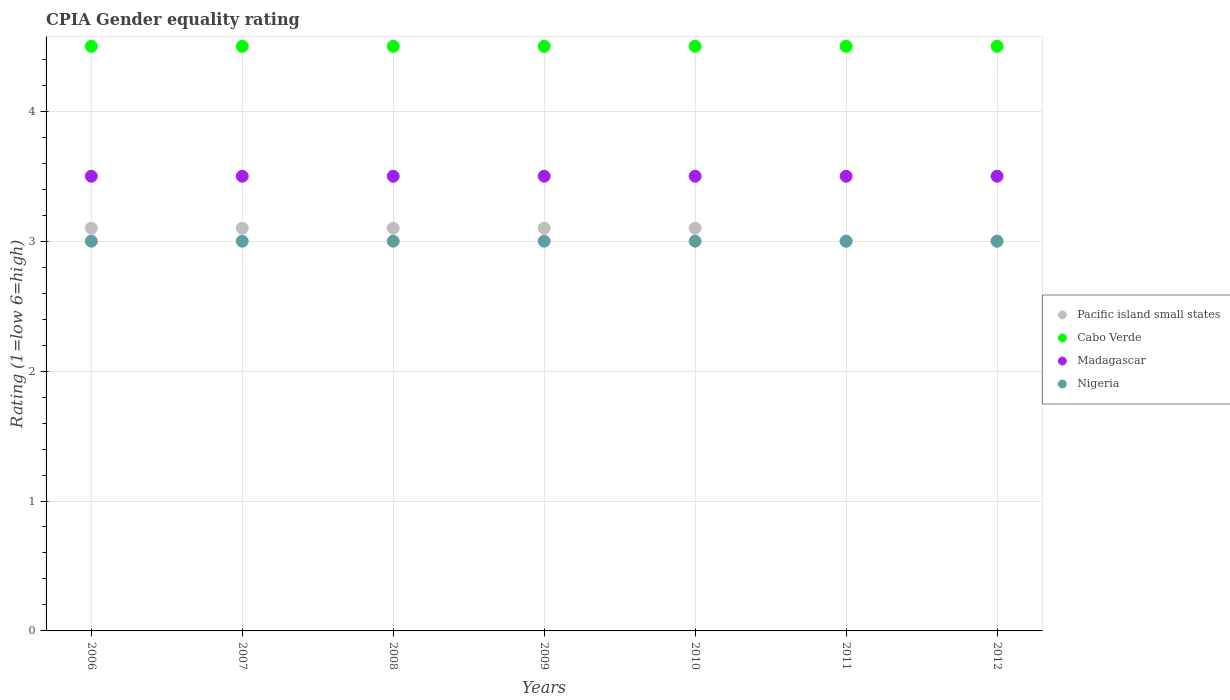Across all years, what is the minimum CPIA rating in Pacific island small states?
Offer a terse response. 3. What is the total CPIA rating in Nigeria in the graph?
Provide a short and direct response. 21. What is the difference between the CPIA rating in Madagascar in 2008 and that in 2012?
Make the answer very short. 0. What is the difference between the CPIA rating in Nigeria in 2007 and the CPIA rating in Cabo Verde in 2010?
Make the answer very short. -1.5. What is the average CPIA rating in Nigeria per year?
Offer a terse response. 3. Is the difference between the CPIA rating in Pacific island small states in 2006 and 2008 greater than the difference between the CPIA rating in Cabo Verde in 2006 and 2008?
Give a very brief answer. No. What is the difference between the highest and the second highest CPIA rating in Cabo Verde?
Provide a short and direct response. 0. In how many years, is the CPIA rating in Nigeria greater than the average CPIA rating in Nigeria taken over all years?
Ensure brevity in your answer.  0. Does the CPIA rating in Nigeria monotonically increase over the years?
Give a very brief answer. No. Is the CPIA rating in Nigeria strictly greater than the CPIA rating in Pacific island small states over the years?
Provide a succinct answer. No. Is the CPIA rating in Pacific island small states strictly less than the CPIA rating in Madagascar over the years?
Provide a succinct answer. Yes. How many dotlines are there?
Make the answer very short. 4. Are the values on the major ticks of Y-axis written in scientific E-notation?
Make the answer very short. No. What is the title of the graph?
Your response must be concise. CPIA Gender equality rating. What is the label or title of the Y-axis?
Offer a terse response. Rating (1=low 6=high). What is the Rating (1=low 6=high) in Cabo Verde in 2006?
Provide a succinct answer. 4.5. What is the Rating (1=low 6=high) in Nigeria in 2006?
Keep it short and to the point. 3. What is the Rating (1=low 6=high) of Pacific island small states in 2008?
Offer a very short reply. 3.1. What is the Rating (1=low 6=high) in Madagascar in 2008?
Provide a succinct answer. 3.5. What is the Rating (1=low 6=high) of Cabo Verde in 2009?
Give a very brief answer. 4.5. What is the Rating (1=low 6=high) of Cabo Verde in 2010?
Ensure brevity in your answer.  4.5. What is the Rating (1=low 6=high) in Madagascar in 2010?
Keep it short and to the point. 3.5. What is the Rating (1=low 6=high) in Pacific island small states in 2011?
Offer a very short reply. 3. What is the Rating (1=low 6=high) of Madagascar in 2011?
Your answer should be very brief. 3.5. What is the Rating (1=low 6=high) of Madagascar in 2012?
Make the answer very short. 3.5. Across all years, what is the minimum Rating (1=low 6=high) of Pacific island small states?
Offer a terse response. 3. What is the total Rating (1=low 6=high) of Cabo Verde in the graph?
Provide a short and direct response. 31.5. What is the difference between the Rating (1=low 6=high) in Pacific island small states in 2006 and that in 2007?
Make the answer very short. 0. What is the difference between the Rating (1=low 6=high) of Cabo Verde in 2006 and that in 2007?
Make the answer very short. 0. What is the difference between the Rating (1=low 6=high) in Madagascar in 2006 and that in 2007?
Your answer should be very brief. 0. What is the difference between the Rating (1=low 6=high) in Pacific island small states in 2006 and that in 2009?
Your response must be concise. 0. What is the difference between the Rating (1=low 6=high) in Cabo Verde in 2006 and that in 2009?
Ensure brevity in your answer.  0. What is the difference between the Rating (1=low 6=high) in Madagascar in 2006 and that in 2009?
Provide a succinct answer. 0. What is the difference between the Rating (1=low 6=high) in Nigeria in 2006 and that in 2009?
Ensure brevity in your answer.  0. What is the difference between the Rating (1=low 6=high) in Pacific island small states in 2006 and that in 2010?
Your answer should be very brief. 0. What is the difference between the Rating (1=low 6=high) of Cabo Verde in 2006 and that in 2010?
Your answer should be compact. 0. What is the difference between the Rating (1=low 6=high) in Pacific island small states in 2006 and that in 2011?
Offer a terse response. 0.1. What is the difference between the Rating (1=low 6=high) in Nigeria in 2006 and that in 2011?
Ensure brevity in your answer.  0. What is the difference between the Rating (1=low 6=high) in Cabo Verde in 2006 and that in 2012?
Give a very brief answer. 0. What is the difference between the Rating (1=low 6=high) of Madagascar in 2006 and that in 2012?
Offer a very short reply. 0. What is the difference between the Rating (1=low 6=high) of Cabo Verde in 2007 and that in 2009?
Offer a very short reply. 0. What is the difference between the Rating (1=low 6=high) of Nigeria in 2007 and that in 2009?
Give a very brief answer. 0. What is the difference between the Rating (1=low 6=high) of Cabo Verde in 2007 and that in 2010?
Your response must be concise. 0. What is the difference between the Rating (1=low 6=high) of Nigeria in 2007 and that in 2010?
Your answer should be very brief. 0. What is the difference between the Rating (1=low 6=high) of Pacific island small states in 2007 and that in 2011?
Provide a succinct answer. 0.1. What is the difference between the Rating (1=low 6=high) in Nigeria in 2007 and that in 2011?
Your answer should be compact. 0. What is the difference between the Rating (1=low 6=high) of Madagascar in 2008 and that in 2009?
Ensure brevity in your answer.  0. What is the difference between the Rating (1=low 6=high) in Nigeria in 2008 and that in 2009?
Your answer should be compact. 0. What is the difference between the Rating (1=low 6=high) in Madagascar in 2008 and that in 2010?
Make the answer very short. 0. What is the difference between the Rating (1=low 6=high) in Nigeria in 2008 and that in 2010?
Your answer should be very brief. 0. What is the difference between the Rating (1=low 6=high) in Pacific island small states in 2009 and that in 2010?
Offer a terse response. 0. What is the difference between the Rating (1=low 6=high) of Madagascar in 2009 and that in 2010?
Offer a terse response. 0. What is the difference between the Rating (1=low 6=high) in Nigeria in 2009 and that in 2010?
Your answer should be compact. 0. What is the difference between the Rating (1=low 6=high) of Pacific island small states in 2009 and that in 2011?
Your answer should be compact. 0.1. What is the difference between the Rating (1=low 6=high) in Madagascar in 2009 and that in 2012?
Ensure brevity in your answer.  0. What is the difference between the Rating (1=low 6=high) of Nigeria in 2009 and that in 2012?
Give a very brief answer. 0. What is the difference between the Rating (1=low 6=high) of Cabo Verde in 2010 and that in 2011?
Your answer should be compact. 0. What is the difference between the Rating (1=low 6=high) in Madagascar in 2010 and that in 2011?
Ensure brevity in your answer.  0. What is the difference between the Rating (1=low 6=high) of Cabo Verde in 2010 and that in 2012?
Provide a succinct answer. 0. What is the difference between the Rating (1=low 6=high) in Madagascar in 2010 and that in 2012?
Give a very brief answer. 0. What is the difference between the Rating (1=low 6=high) of Pacific island small states in 2011 and that in 2012?
Provide a short and direct response. 0. What is the difference between the Rating (1=low 6=high) of Cabo Verde in 2011 and that in 2012?
Ensure brevity in your answer.  0. What is the difference between the Rating (1=low 6=high) in Madagascar in 2011 and that in 2012?
Ensure brevity in your answer.  0. What is the difference between the Rating (1=low 6=high) of Nigeria in 2011 and that in 2012?
Ensure brevity in your answer.  0. What is the difference between the Rating (1=low 6=high) of Pacific island small states in 2006 and the Rating (1=low 6=high) of Madagascar in 2007?
Offer a terse response. -0.4. What is the difference between the Rating (1=low 6=high) in Pacific island small states in 2006 and the Rating (1=low 6=high) in Nigeria in 2007?
Your answer should be compact. 0.1. What is the difference between the Rating (1=low 6=high) of Pacific island small states in 2006 and the Rating (1=low 6=high) of Cabo Verde in 2008?
Provide a short and direct response. -1.4. What is the difference between the Rating (1=low 6=high) of Pacific island small states in 2006 and the Rating (1=low 6=high) of Madagascar in 2008?
Offer a very short reply. -0.4. What is the difference between the Rating (1=low 6=high) of Cabo Verde in 2006 and the Rating (1=low 6=high) of Nigeria in 2008?
Provide a short and direct response. 1.5. What is the difference between the Rating (1=low 6=high) in Pacific island small states in 2006 and the Rating (1=low 6=high) in Cabo Verde in 2009?
Your response must be concise. -1.4. What is the difference between the Rating (1=low 6=high) of Pacific island small states in 2006 and the Rating (1=low 6=high) of Madagascar in 2009?
Your response must be concise. -0.4. What is the difference between the Rating (1=low 6=high) in Pacific island small states in 2006 and the Rating (1=low 6=high) in Nigeria in 2009?
Your answer should be compact. 0.1. What is the difference between the Rating (1=low 6=high) of Cabo Verde in 2006 and the Rating (1=low 6=high) of Nigeria in 2009?
Keep it short and to the point. 1.5. What is the difference between the Rating (1=low 6=high) in Pacific island small states in 2006 and the Rating (1=low 6=high) in Cabo Verde in 2010?
Provide a short and direct response. -1.4. What is the difference between the Rating (1=low 6=high) in Pacific island small states in 2006 and the Rating (1=low 6=high) in Nigeria in 2010?
Ensure brevity in your answer.  0.1. What is the difference between the Rating (1=low 6=high) in Pacific island small states in 2006 and the Rating (1=low 6=high) in Madagascar in 2011?
Provide a short and direct response. -0.4. What is the difference between the Rating (1=low 6=high) of Cabo Verde in 2006 and the Rating (1=low 6=high) of Madagascar in 2011?
Provide a short and direct response. 1. What is the difference between the Rating (1=low 6=high) of Pacific island small states in 2006 and the Rating (1=low 6=high) of Cabo Verde in 2012?
Provide a succinct answer. -1.4. What is the difference between the Rating (1=low 6=high) in Pacific island small states in 2006 and the Rating (1=low 6=high) in Nigeria in 2012?
Ensure brevity in your answer.  0.1. What is the difference between the Rating (1=low 6=high) in Pacific island small states in 2007 and the Rating (1=low 6=high) in Cabo Verde in 2008?
Provide a succinct answer. -1.4. What is the difference between the Rating (1=low 6=high) in Cabo Verde in 2007 and the Rating (1=low 6=high) in Madagascar in 2008?
Make the answer very short. 1. What is the difference between the Rating (1=low 6=high) in Cabo Verde in 2007 and the Rating (1=low 6=high) in Nigeria in 2008?
Your answer should be very brief. 1.5. What is the difference between the Rating (1=low 6=high) in Madagascar in 2007 and the Rating (1=low 6=high) in Nigeria in 2008?
Your answer should be very brief. 0.5. What is the difference between the Rating (1=low 6=high) in Pacific island small states in 2007 and the Rating (1=low 6=high) in Nigeria in 2009?
Your response must be concise. 0.1. What is the difference between the Rating (1=low 6=high) in Pacific island small states in 2007 and the Rating (1=low 6=high) in Cabo Verde in 2010?
Offer a terse response. -1.4. What is the difference between the Rating (1=low 6=high) of Pacific island small states in 2007 and the Rating (1=low 6=high) of Madagascar in 2010?
Your answer should be very brief. -0.4. What is the difference between the Rating (1=low 6=high) of Pacific island small states in 2007 and the Rating (1=low 6=high) of Nigeria in 2010?
Your response must be concise. 0.1. What is the difference between the Rating (1=low 6=high) in Cabo Verde in 2007 and the Rating (1=low 6=high) in Madagascar in 2010?
Provide a short and direct response. 1. What is the difference between the Rating (1=low 6=high) of Cabo Verde in 2007 and the Rating (1=low 6=high) of Nigeria in 2010?
Your answer should be very brief. 1.5. What is the difference between the Rating (1=low 6=high) of Pacific island small states in 2007 and the Rating (1=low 6=high) of Cabo Verde in 2011?
Give a very brief answer. -1.4. What is the difference between the Rating (1=low 6=high) of Pacific island small states in 2007 and the Rating (1=low 6=high) of Nigeria in 2011?
Keep it short and to the point. 0.1. What is the difference between the Rating (1=low 6=high) of Madagascar in 2007 and the Rating (1=low 6=high) of Nigeria in 2011?
Make the answer very short. 0.5. What is the difference between the Rating (1=low 6=high) in Pacific island small states in 2007 and the Rating (1=low 6=high) in Cabo Verde in 2012?
Offer a terse response. -1.4. What is the difference between the Rating (1=low 6=high) in Pacific island small states in 2007 and the Rating (1=low 6=high) in Madagascar in 2012?
Your answer should be very brief. -0.4. What is the difference between the Rating (1=low 6=high) of Cabo Verde in 2007 and the Rating (1=low 6=high) of Nigeria in 2012?
Give a very brief answer. 1.5. What is the difference between the Rating (1=low 6=high) in Madagascar in 2007 and the Rating (1=low 6=high) in Nigeria in 2012?
Your answer should be compact. 0.5. What is the difference between the Rating (1=low 6=high) of Pacific island small states in 2008 and the Rating (1=low 6=high) of Madagascar in 2009?
Your response must be concise. -0.4. What is the difference between the Rating (1=low 6=high) in Pacific island small states in 2008 and the Rating (1=low 6=high) in Nigeria in 2009?
Offer a terse response. 0.1. What is the difference between the Rating (1=low 6=high) in Cabo Verde in 2008 and the Rating (1=low 6=high) in Madagascar in 2009?
Your answer should be compact. 1. What is the difference between the Rating (1=low 6=high) in Pacific island small states in 2008 and the Rating (1=low 6=high) in Nigeria in 2010?
Provide a short and direct response. 0.1. What is the difference between the Rating (1=low 6=high) of Cabo Verde in 2008 and the Rating (1=low 6=high) of Madagascar in 2010?
Ensure brevity in your answer.  1. What is the difference between the Rating (1=low 6=high) in Pacific island small states in 2008 and the Rating (1=low 6=high) in Cabo Verde in 2011?
Make the answer very short. -1.4. What is the difference between the Rating (1=low 6=high) in Cabo Verde in 2008 and the Rating (1=low 6=high) in Madagascar in 2011?
Your response must be concise. 1. What is the difference between the Rating (1=low 6=high) of Madagascar in 2008 and the Rating (1=low 6=high) of Nigeria in 2011?
Offer a very short reply. 0.5. What is the difference between the Rating (1=low 6=high) of Pacific island small states in 2008 and the Rating (1=low 6=high) of Cabo Verde in 2012?
Your answer should be very brief. -1.4. What is the difference between the Rating (1=low 6=high) of Cabo Verde in 2008 and the Rating (1=low 6=high) of Madagascar in 2012?
Give a very brief answer. 1. What is the difference between the Rating (1=low 6=high) in Cabo Verde in 2008 and the Rating (1=low 6=high) in Nigeria in 2012?
Keep it short and to the point. 1.5. What is the difference between the Rating (1=low 6=high) of Pacific island small states in 2009 and the Rating (1=low 6=high) of Cabo Verde in 2010?
Give a very brief answer. -1.4. What is the difference between the Rating (1=low 6=high) of Pacific island small states in 2009 and the Rating (1=low 6=high) of Nigeria in 2010?
Your response must be concise. 0.1. What is the difference between the Rating (1=low 6=high) of Cabo Verde in 2009 and the Rating (1=low 6=high) of Madagascar in 2010?
Offer a very short reply. 1. What is the difference between the Rating (1=low 6=high) in Cabo Verde in 2009 and the Rating (1=low 6=high) in Madagascar in 2011?
Ensure brevity in your answer.  1. What is the difference between the Rating (1=low 6=high) in Madagascar in 2009 and the Rating (1=low 6=high) in Nigeria in 2011?
Keep it short and to the point. 0.5. What is the difference between the Rating (1=low 6=high) of Pacific island small states in 2009 and the Rating (1=low 6=high) of Nigeria in 2012?
Your response must be concise. 0.1. What is the difference between the Rating (1=low 6=high) in Cabo Verde in 2009 and the Rating (1=low 6=high) in Madagascar in 2012?
Offer a terse response. 1. What is the difference between the Rating (1=low 6=high) in Cabo Verde in 2009 and the Rating (1=low 6=high) in Nigeria in 2012?
Make the answer very short. 1.5. What is the difference between the Rating (1=low 6=high) in Pacific island small states in 2010 and the Rating (1=low 6=high) in Madagascar in 2011?
Ensure brevity in your answer.  -0.4. What is the difference between the Rating (1=low 6=high) of Pacific island small states in 2010 and the Rating (1=low 6=high) of Nigeria in 2011?
Ensure brevity in your answer.  0.1. What is the difference between the Rating (1=low 6=high) of Cabo Verde in 2010 and the Rating (1=low 6=high) of Nigeria in 2011?
Make the answer very short. 1.5. What is the difference between the Rating (1=low 6=high) in Madagascar in 2010 and the Rating (1=low 6=high) in Nigeria in 2011?
Your response must be concise. 0.5. What is the difference between the Rating (1=low 6=high) in Pacific island small states in 2010 and the Rating (1=low 6=high) in Madagascar in 2012?
Ensure brevity in your answer.  -0.4. What is the difference between the Rating (1=low 6=high) in Pacific island small states in 2010 and the Rating (1=low 6=high) in Nigeria in 2012?
Your response must be concise. 0.1. What is the difference between the Rating (1=low 6=high) in Cabo Verde in 2010 and the Rating (1=low 6=high) in Madagascar in 2012?
Ensure brevity in your answer.  1. What is the difference between the Rating (1=low 6=high) in Cabo Verde in 2011 and the Rating (1=low 6=high) in Nigeria in 2012?
Provide a short and direct response. 1.5. What is the difference between the Rating (1=low 6=high) in Madagascar in 2011 and the Rating (1=low 6=high) in Nigeria in 2012?
Offer a terse response. 0.5. What is the average Rating (1=low 6=high) of Pacific island small states per year?
Provide a succinct answer. 3.07. What is the average Rating (1=low 6=high) in Madagascar per year?
Keep it short and to the point. 3.5. What is the average Rating (1=low 6=high) in Nigeria per year?
Keep it short and to the point. 3. In the year 2006, what is the difference between the Rating (1=low 6=high) in Pacific island small states and Rating (1=low 6=high) in Cabo Verde?
Your answer should be very brief. -1.4. In the year 2006, what is the difference between the Rating (1=low 6=high) of Cabo Verde and Rating (1=low 6=high) of Nigeria?
Keep it short and to the point. 1.5. In the year 2006, what is the difference between the Rating (1=low 6=high) in Madagascar and Rating (1=low 6=high) in Nigeria?
Keep it short and to the point. 0.5. In the year 2007, what is the difference between the Rating (1=low 6=high) of Pacific island small states and Rating (1=low 6=high) of Madagascar?
Your answer should be compact. -0.4. In the year 2007, what is the difference between the Rating (1=low 6=high) of Pacific island small states and Rating (1=low 6=high) of Nigeria?
Provide a short and direct response. 0.1. In the year 2008, what is the difference between the Rating (1=low 6=high) of Pacific island small states and Rating (1=low 6=high) of Madagascar?
Provide a short and direct response. -0.4. In the year 2008, what is the difference between the Rating (1=low 6=high) in Cabo Verde and Rating (1=low 6=high) in Madagascar?
Your response must be concise. 1. In the year 2008, what is the difference between the Rating (1=low 6=high) of Madagascar and Rating (1=low 6=high) of Nigeria?
Keep it short and to the point. 0.5. In the year 2009, what is the difference between the Rating (1=low 6=high) of Pacific island small states and Rating (1=low 6=high) of Madagascar?
Your response must be concise. -0.4. In the year 2009, what is the difference between the Rating (1=low 6=high) in Cabo Verde and Rating (1=low 6=high) in Madagascar?
Provide a succinct answer. 1. In the year 2009, what is the difference between the Rating (1=low 6=high) in Cabo Verde and Rating (1=low 6=high) in Nigeria?
Give a very brief answer. 1.5. In the year 2009, what is the difference between the Rating (1=low 6=high) of Madagascar and Rating (1=low 6=high) of Nigeria?
Give a very brief answer. 0.5. In the year 2010, what is the difference between the Rating (1=low 6=high) of Pacific island small states and Rating (1=low 6=high) of Cabo Verde?
Make the answer very short. -1.4. In the year 2010, what is the difference between the Rating (1=low 6=high) of Pacific island small states and Rating (1=low 6=high) of Madagascar?
Provide a succinct answer. -0.4. In the year 2010, what is the difference between the Rating (1=low 6=high) of Cabo Verde and Rating (1=low 6=high) of Madagascar?
Give a very brief answer. 1. In the year 2010, what is the difference between the Rating (1=low 6=high) of Madagascar and Rating (1=low 6=high) of Nigeria?
Keep it short and to the point. 0.5. In the year 2011, what is the difference between the Rating (1=low 6=high) in Pacific island small states and Rating (1=low 6=high) in Cabo Verde?
Give a very brief answer. -1.5. In the year 2011, what is the difference between the Rating (1=low 6=high) in Pacific island small states and Rating (1=low 6=high) in Madagascar?
Make the answer very short. -0.5. In the year 2012, what is the difference between the Rating (1=low 6=high) in Pacific island small states and Rating (1=low 6=high) in Cabo Verde?
Make the answer very short. -1.5. In the year 2012, what is the difference between the Rating (1=low 6=high) of Pacific island small states and Rating (1=low 6=high) of Madagascar?
Ensure brevity in your answer.  -0.5. In the year 2012, what is the difference between the Rating (1=low 6=high) of Pacific island small states and Rating (1=low 6=high) of Nigeria?
Ensure brevity in your answer.  0. In the year 2012, what is the difference between the Rating (1=low 6=high) in Cabo Verde and Rating (1=low 6=high) in Madagascar?
Offer a terse response. 1. In the year 2012, what is the difference between the Rating (1=low 6=high) in Madagascar and Rating (1=low 6=high) in Nigeria?
Provide a succinct answer. 0.5. What is the ratio of the Rating (1=low 6=high) of Pacific island small states in 2006 to that in 2007?
Offer a very short reply. 1. What is the ratio of the Rating (1=low 6=high) in Nigeria in 2006 to that in 2007?
Your answer should be very brief. 1. What is the ratio of the Rating (1=low 6=high) of Madagascar in 2006 to that in 2008?
Make the answer very short. 1. What is the ratio of the Rating (1=low 6=high) of Pacific island small states in 2006 to that in 2009?
Your response must be concise. 1. What is the ratio of the Rating (1=low 6=high) of Cabo Verde in 2006 to that in 2009?
Your response must be concise. 1. What is the ratio of the Rating (1=low 6=high) in Madagascar in 2006 to that in 2009?
Your response must be concise. 1. What is the ratio of the Rating (1=low 6=high) in Madagascar in 2006 to that in 2010?
Provide a succinct answer. 1. What is the ratio of the Rating (1=low 6=high) of Nigeria in 2006 to that in 2010?
Keep it short and to the point. 1. What is the ratio of the Rating (1=low 6=high) of Pacific island small states in 2006 to that in 2011?
Your response must be concise. 1.03. What is the ratio of the Rating (1=low 6=high) in Cabo Verde in 2006 to that in 2011?
Give a very brief answer. 1. What is the ratio of the Rating (1=low 6=high) in Pacific island small states in 2006 to that in 2012?
Ensure brevity in your answer.  1.03. What is the ratio of the Rating (1=low 6=high) of Cabo Verde in 2006 to that in 2012?
Keep it short and to the point. 1. What is the ratio of the Rating (1=low 6=high) of Nigeria in 2006 to that in 2012?
Provide a succinct answer. 1. What is the ratio of the Rating (1=low 6=high) of Cabo Verde in 2007 to that in 2008?
Provide a short and direct response. 1. What is the ratio of the Rating (1=low 6=high) of Nigeria in 2007 to that in 2008?
Provide a succinct answer. 1. What is the ratio of the Rating (1=low 6=high) in Madagascar in 2007 to that in 2009?
Your answer should be compact. 1. What is the ratio of the Rating (1=low 6=high) in Pacific island small states in 2007 to that in 2010?
Ensure brevity in your answer.  1. What is the ratio of the Rating (1=low 6=high) in Cabo Verde in 2007 to that in 2010?
Ensure brevity in your answer.  1. What is the ratio of the Rating (1=low 6=high) of Cabo Verde in 2007 to that in 2011?
Ensure brevity in your answer.  1. What is the ratio of the Rating (1=low 6=high) in Nigeria in 2007 to that in 2011?
Your response must be concise. 1. What is the ratio of the Rating (1=low 6=high) in Pacific island small states in 2007 to that in 2012?
Offer a very short reply. 1.03. What is the ratio of the Rating (1=low 6=high) of Cabo Verde in 2008 to that in 2009?
Your answer should be compact. 1. What is the ratio of the Rating (1=low 6=high) in Madagascar in 2008 to that in 2009?
Provide a succinct answer. 1. What is the ratio of the Rating (1=low 6=high) of Nigeria in 2008 to that in 2009?
Offer a very short reply. 1. What is the ratio of the Rating (1=low 6=high) in Pacific island small states in 2008 to that in 2011?
Offer a terse response. 1.03. What is the ratio of the Rating (1=low 6=high) in Cabo Verde in 2008 to that in 2011?
Give a very brief answer. 1. What is the ratio of the Rating (1=low 6=high) of Cabo Verde in 2008 to that in 2012?
Offer a very short reply. 1. What is the ratio of the Rating (1=low 6=high) in Madagascar in 2008 to that in 2012?
Ensure brevity in your answer.  1. What is the ratio of the Rating (1=low 6=high) of Nigeria in 2008 to that in 2012?
Your response must be concise. 1. What is the ratio of the Rating (1=low 6=high) of Madagascar in 2009 to that in 2010?
Your response must be concise. 1. What is the ratio of the Rating (1=low 6=high) of Pacific island small states in 2009 to that in 2012?
Ensure brevity in your answer.  1.03. What is the ratio of the Rating (1=low 6=high) of Cabo Verde in 2009 to that in 2012?
Your answer should be compact. 1. What is the ratio of the Rating (1=low 6=high) of Nigeria in 2009 to that in 2012?
Give a very brief answer. 1. What is the ratio of the Rating (1=low 6=high) of Madagascar in 2010 to that in 2011?
Your answer should be compact. 1. What is the ratio of the Rating (1=low 6=high) in Nigeria in 2010 to that in 2011?
Your response must be concise. 1. What is the ratio of the Rating (1=low 6=high) of Madagascar in 2010 to that in 2012?
Provide a short and direct response. 1. What is the ratio of the Rating (1=low 6=high) of Pacific island small states in 2011 to that in 2012?
Offer a very short reply. 1. What is the ratio of the Rating (1=low 6=high) in Cabo Verde in 2011 to that in 2012?
Provide a succinct answer. 1. What is the ratio of the Rating (1=low 6=high) of Nigeria in 2011 to that in 2012?
Make the answer very short. 1. What is the difference between the highest and the second highest Rating (1=low 6=high) in Nigeria?
Offer a very short reply. 0. What is the difference between the highest and the lowest Rating (1=low 6=high) of Cabo Verde?
Your answer should be very brief. 0. What is the difference between the highest and the lowest Rating (1=low 6=high) in Madagascar?
Make the answer very short. 0. 